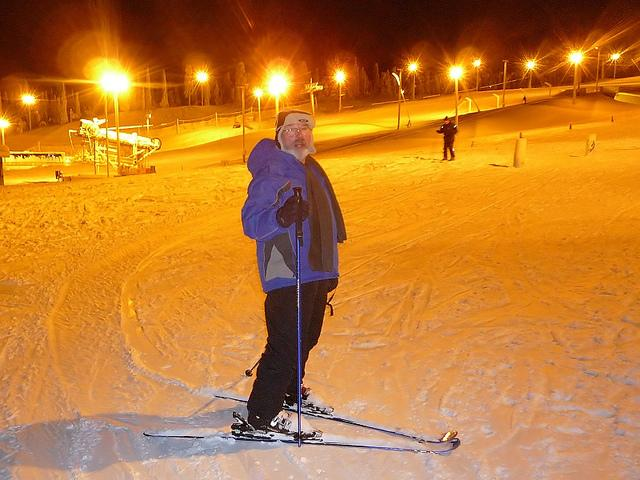Why is the man wearing a hat with earflaps? cold 